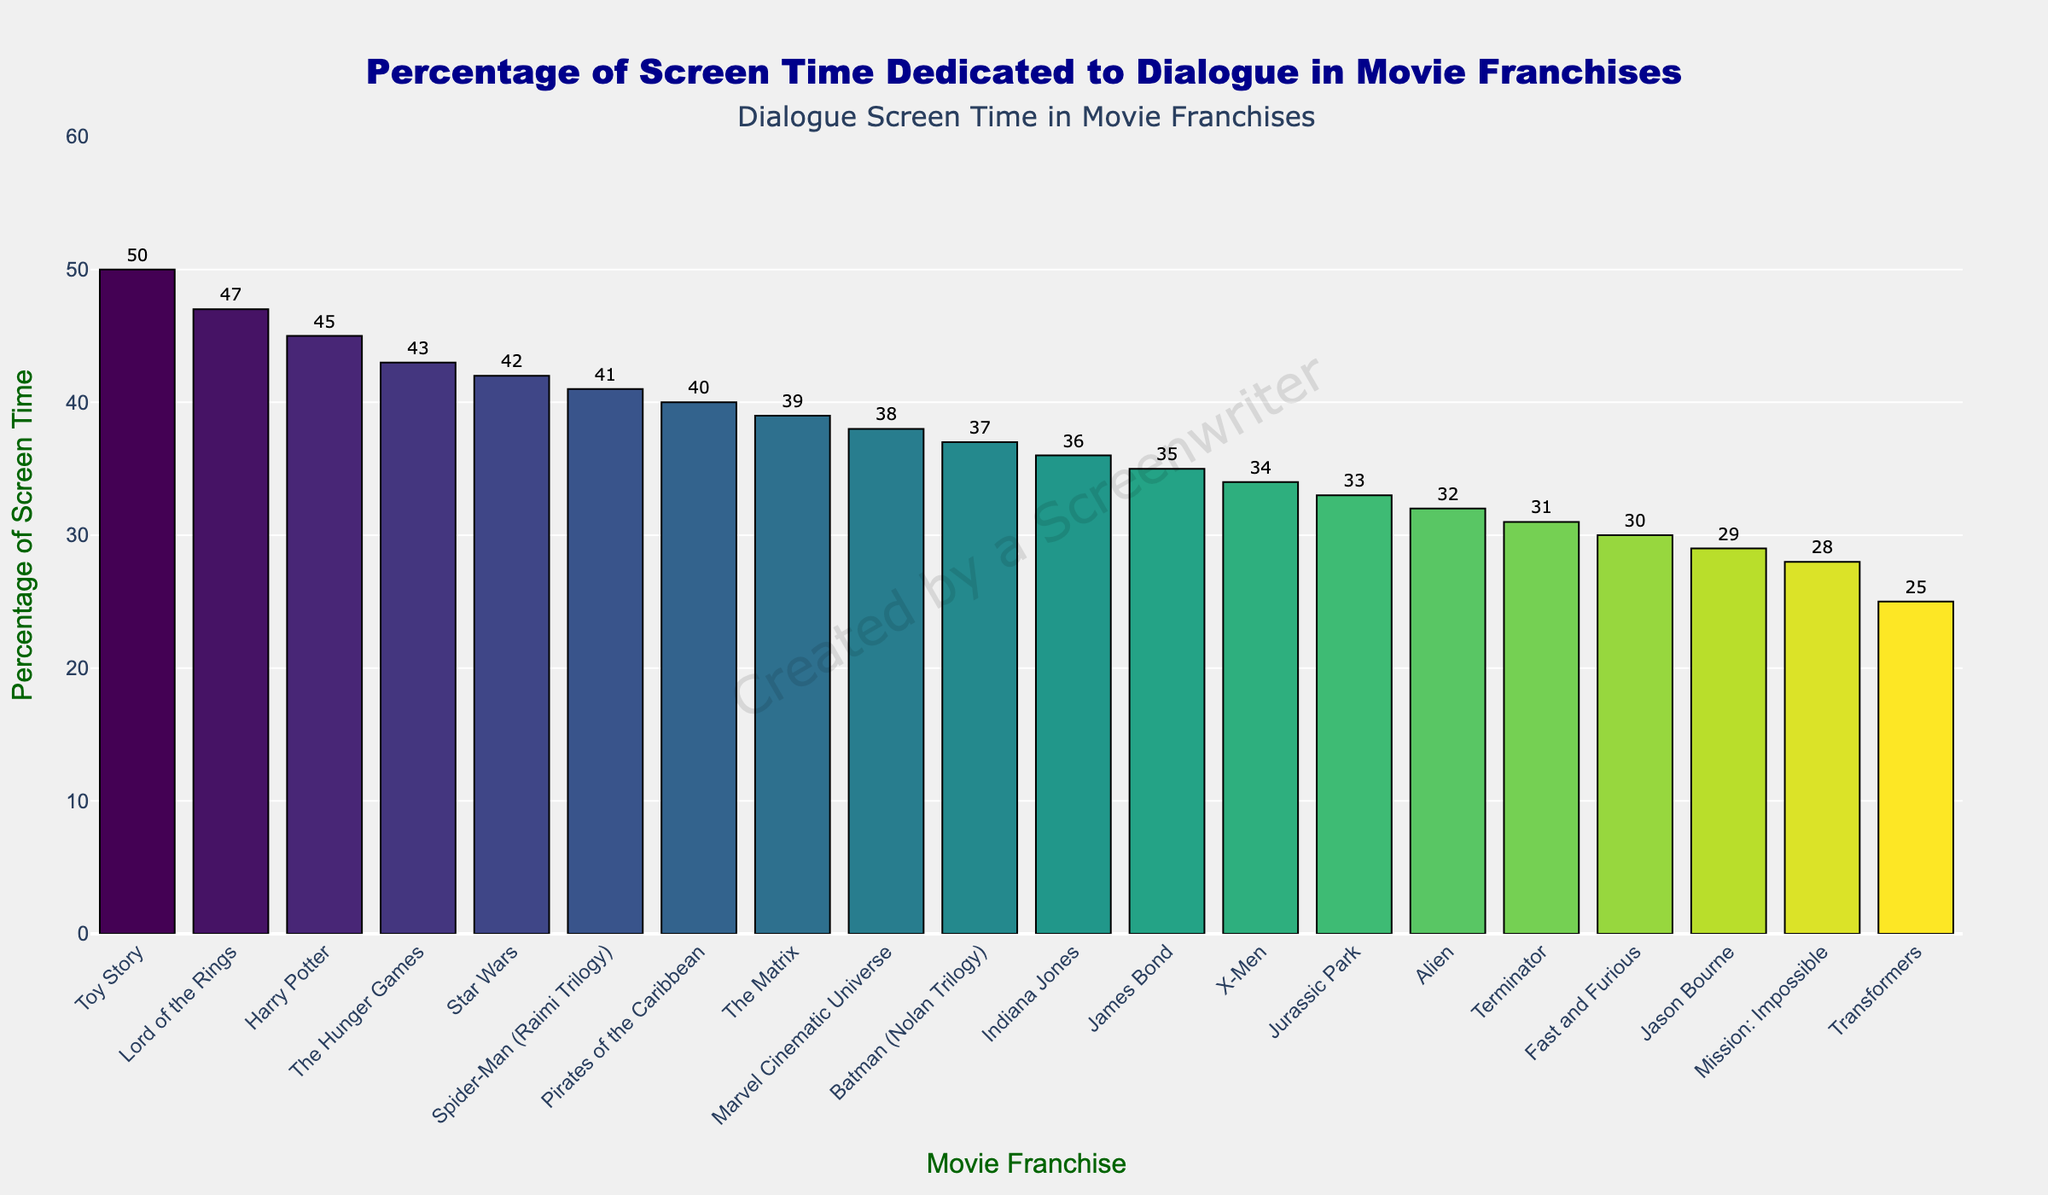What's the franchise with the highest percentage of screen time dedicated to dialogue? The franchise with the highest bar on the chart has the highest percentage of screen time dedicated to dialogue. The tallest bar represents Toy Story.
Answer: Toy Story Which two franchises have the same percentage of screen time dedicated to dialogue? By visually comparing the heights of the bars, two bars have the same height at 36%. These franchises are Indiana Jones and X-Men.
Answer: Indiana Jones and X-Men What's the average percentage of screen time dedicated to dialogue among the Marvel Cinematic Universe, The Matrix, and Harry Potter? The percentages for Marvel Cinematic Universe, The Matrix, and Harry Potter are 38%, 39%, and 45%, respectively. (38 + 39 + 45) / 3 = 122 / 3 ≈ 40.67.
Answer: 40.67 Which franchise has more dialogue screen time, James Bond or Spider-Man (Raimi Trilogy)? By comparing the heights of the bars, Spider-Man (Raimi Trilogy) has a higher percentage (41%) than James Bond (35%).
Answer: Spider-Man (Raimi Trilogy) What's the difference in dialogue screen time percentage between the franchise with the least amount of dialogue and the Marvel Cinematic Universe? The least dialogue screen time is in Transformers with 25%. Marvel Cinematic Universe has 38%. The difference is 38 - 25 = 13%.
Answer: 13 How much more dialogue screen time does Harry Potter have compared to Jurassic Park? Harry Potter has 45% and Jurassic Park has 33%. The difference is 45 - 33 = 12%.
Answer: 12 Which three franchises have nearly equal dialogue screen time, rounded to the nearest percentage point? By visually checking which bars are almost the same height, the franchises are Indiana Jones (36%), Jason Bourne (29%), and James Bond (35%). When rounded, it gives Indiana Jones and X-Men (both 36%) and Jason Bourne whose 29 rounds to 30%.
Answer: Indiana Jones, X-Men, Jason Bourne What is the total percentage of screen time dedicated to dialogue for Fast and Furious, Mission: Impossible, and Alien combined? Fast and Furious has 30%, Mission: Impossible has 28%, and Alien has 32%. The sum is 30 + 28 + 32 = 90%.
Answer: 90 How many franchises have a dialogue screen time percentage higher than 40%? Looking at the bars above the 40% mark, there are 5 franchises: Toy Story (50%), Lord of the Rings (47%), Harry Potter (45%), The Hunger Games (43%), and Star Wars (42%).
Answer: 5 